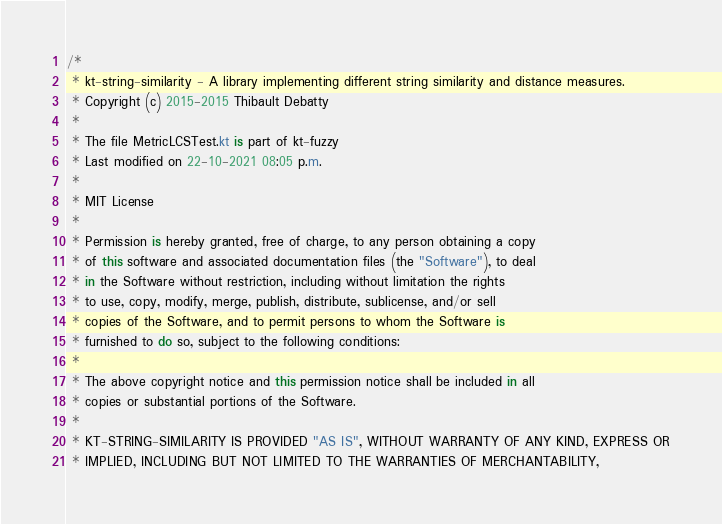Convert code to text. <code><loc_0><loc_0><loc_500><loc_500><_Kotlin_>/*
 * kt-string-similarity - A library implementing different string similarity and distance measures.
 * Copyright (c) 2015-2015 Thibault Debatty
 *
 * The file MetricLCSTest.kt is part of kt-fuzzy
 * Last modified on 22-10-2021 08:05 p.m.
 *
 * MIT License
 *
 * Permission is hereby granted, free of charge, to any person obtaining a copy
 * of this software and associated documentation files (the "Software"), to deal
 * in the Software without restriction, including without limitation the rights
 * to use, copy, modify, merge, publish, distribute, sublicense, and/or sell
 * copies of the Software, and to permit persons to whom the Software is
 * furnished to do so, subject to the following conditions:
 *
 * The above copyright notice and this permission notice shall be included in all
 * copies or substantial portions of the Software.
 *
 * KT-STRING-SIMILARITY IS PROVIDED "AS IS", WITHOUT WARRANTY OF ANY KIND, EXPRESS OR
 * IMPLIED, INCLUDING BUT NOT LIMITED TO THE WARRANTIES OF MERCHANTABILITY,</code> 